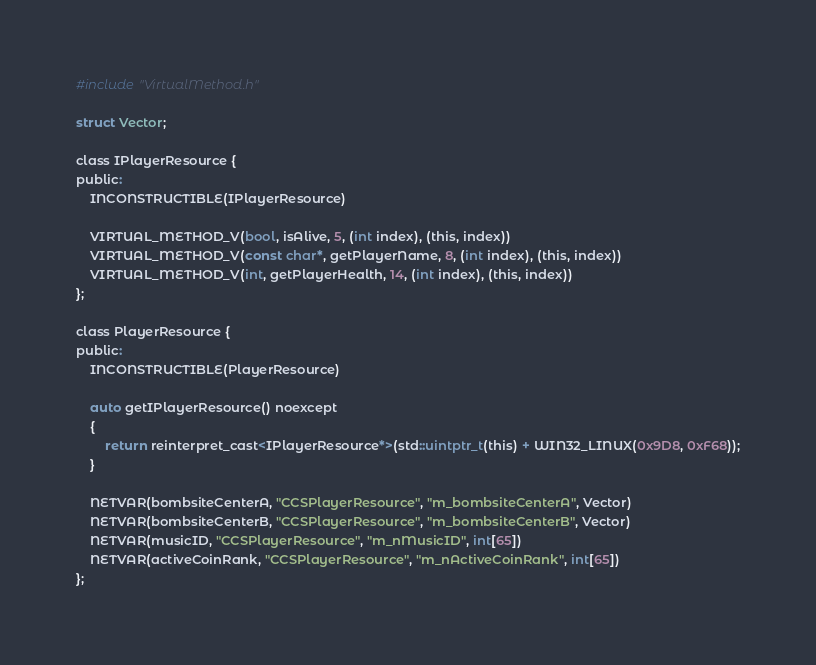<code> <loc_0><loc_0><loc_500><loc_500><_C_>#include "VirtualMethod.h"

struct Vector;

class IPlayerResource {
public:
    INCONSTRUCTIBLE(IPlayerResource)

    VIRTUAL_METHOD_V(bool, isAlive, 5, (int index), (this, index))
    VIRTUAL_METHOD_V(const char*, getPlayerName, 8, (int index), (this, index))
    VIRTUAL_METHOD_V(int, getPlayerHealth, 14, (int index), (this, index))
};

class PlayerResource {
public:
    INCONSTRUCTIBLE(PlayerResource)

    auto getIPlayerResource() noexcept
    {
        return reinterpret_cast<IPlayerResource*>(std::uintptr_t(this) + WIN32_LINUX(0x9D8, 0xF68));
    }

    NETVAR(bombsiteCenterA, "CCSPlayerResource", "m_bombsiteCenterA", Vector)
    NETVAR(bombsiteCenterB, "CCSPlayerResource", "m_bombsiteCenterB", Vector)
    NETVAR(musicID, "CCSPlayerResource", "m_nMusicID", int[65])
    NETVAR(activeCoinRank, "CCSPlayerResource", "m_nActiveCoinRank", int[65])
};
</code> 